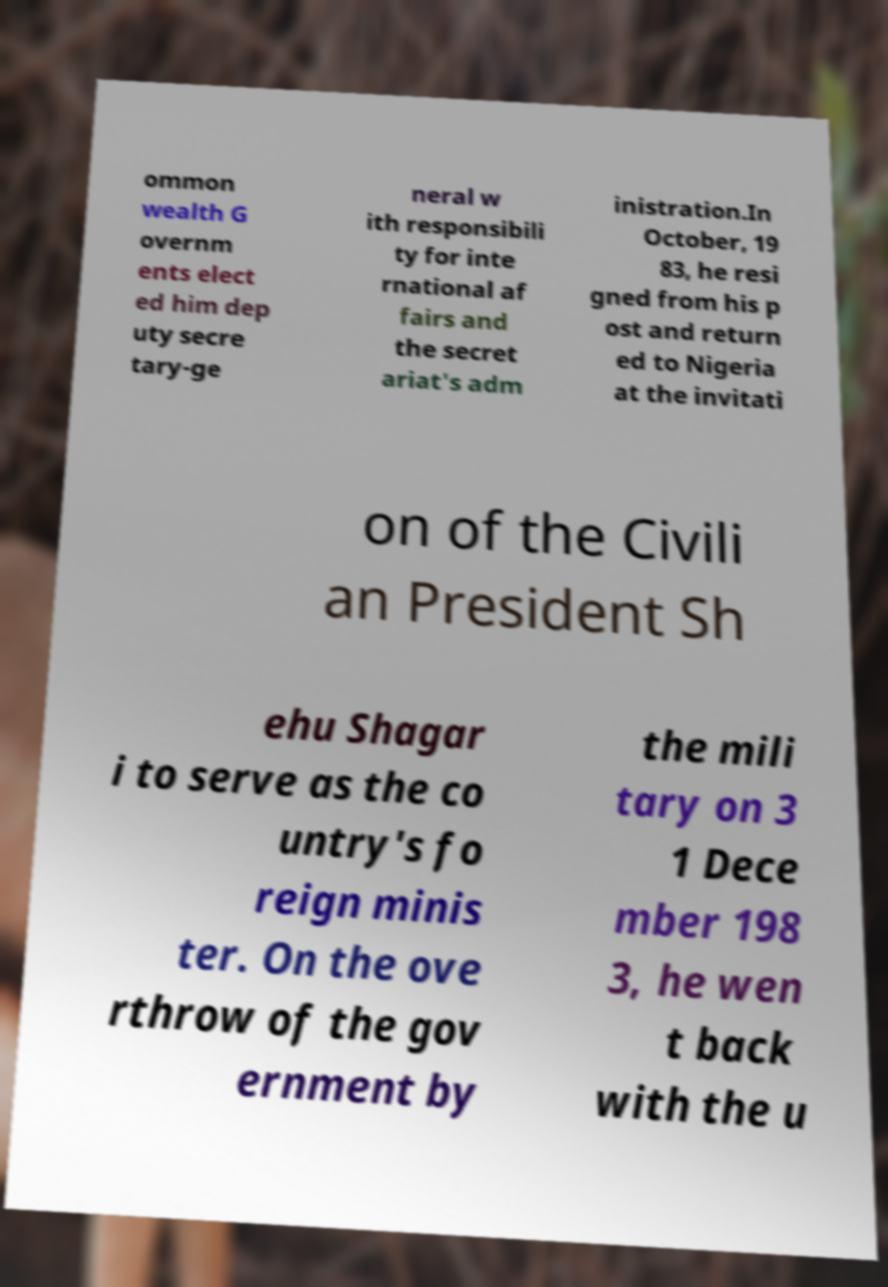Please identify and transcribe the text found in this image. ommon wealth G overnm ents elect ed him dep uty secre tary-ge neral w ith responsibili ty for inte rnational af fairs and the secret ariat's adm inistration.In October, 19 83, he resi gned from his p ost and return ed to Nigeria at the invitati on of the Civili an President Sh ehu Shagar i to serve as the co untry's fo reign minis ter. On the ove rthrow of the gov ernment by the mili tary on 3 1 Dece mber 198 3, he wen t back with the u 